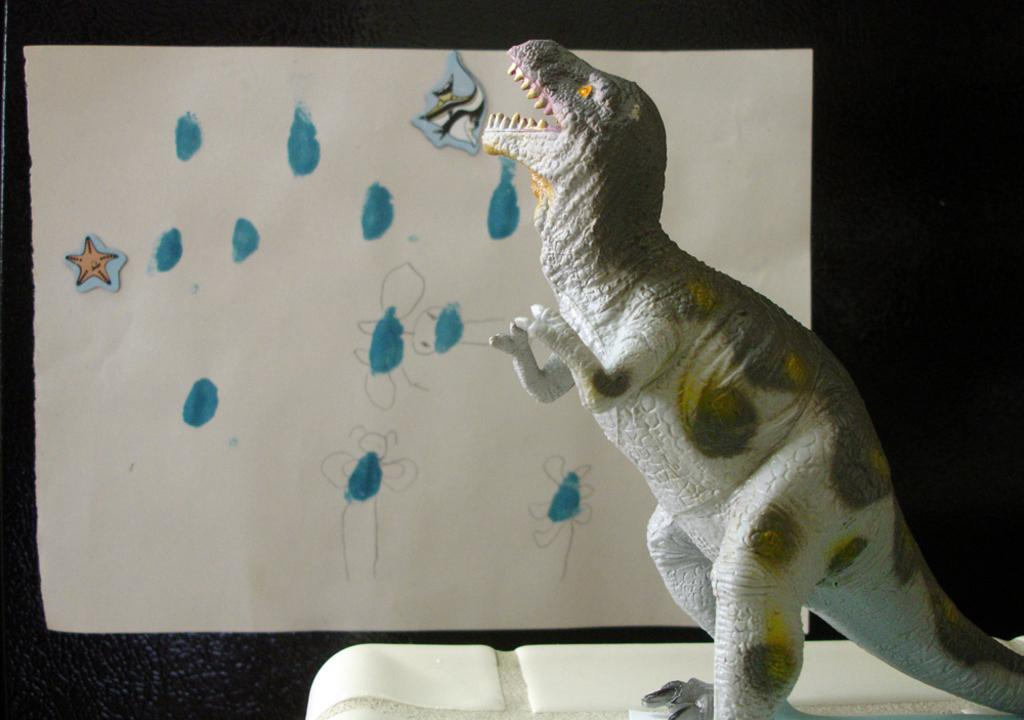What is the main subject of the image? The main subject of the image is a dinosaur statue. What else can be seen in the image besides the dinosaur statue? There is a chart in the middle of the image. What type of wrench is being used to inflate the bubble in the image? There is no wrench or bubble present in the image; it only features a dinosaur statue and a chart. 